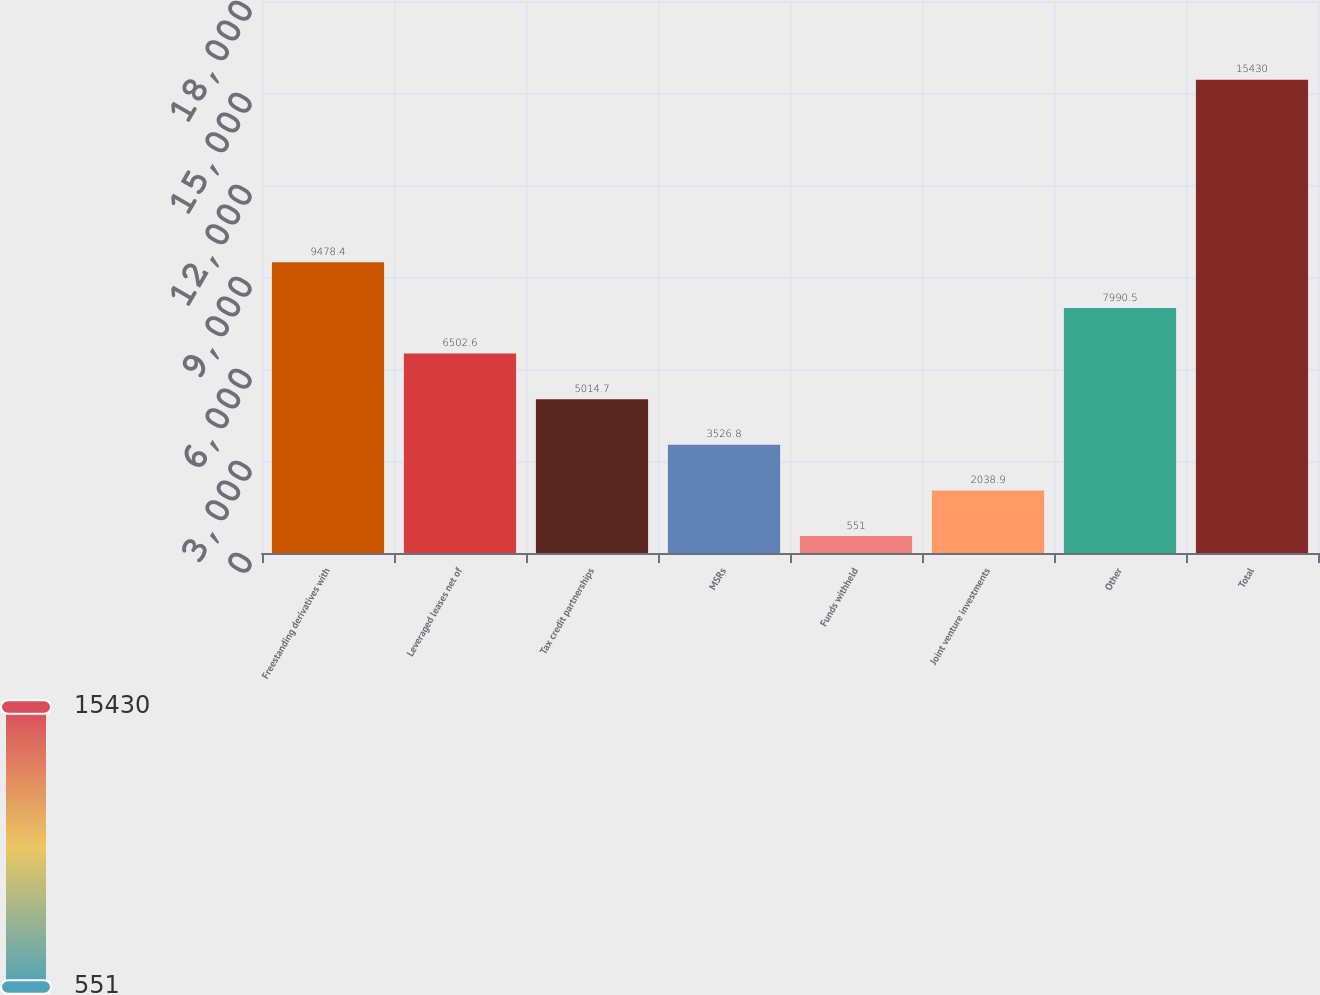Convert chart. <chart><loc_0><loc_0><loc_500><loc_500><bar_chart><fcel>Freestanding derivatives with<fcel>Leveraged leases net of<fcel>Tax credit partnerships<fcel>MSRs<fcel>Funds withheld<fcel>Joint venture investments<fcel>Other<fcel>Total<nl><fcel>9478.4<fcel>6502.6<fcel>5014.7<fcel>3526.8<fcel>551<fcel>2038.9<fcel>7990.5<fcel>15430<nl></chart> 